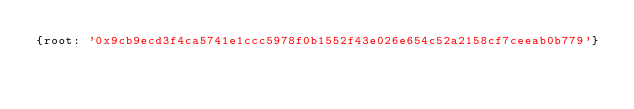Convert code to text. <code><loc_0><loc_0><loc_500><loc_500><_YAML_>{root: '0x9cb9ecd3f4ca5741e1ccc5978f0b1552f43e026e654c52a2158cf7ceeab0b779'}
</code> 